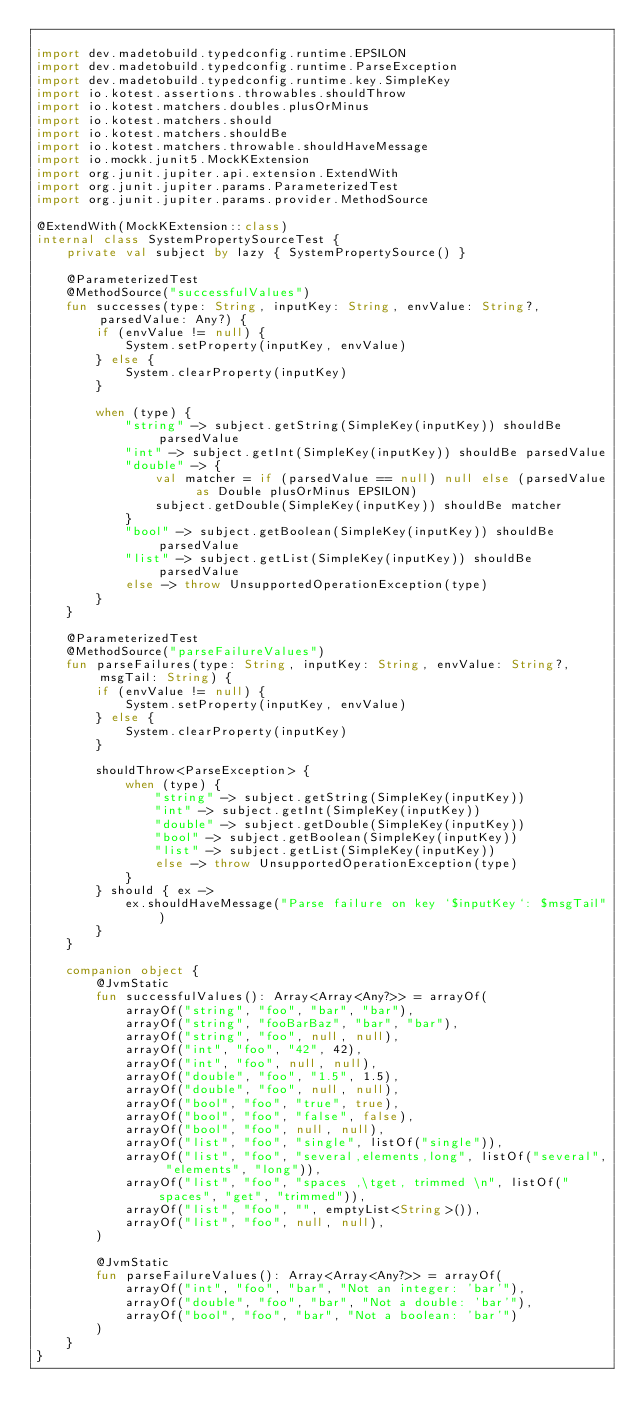<code> <loc_0><loc_0><loc_500><loc_500><_Kotlin_>
import dev.madetobuild.typedconfig.runtime.EPSILON
import dev.madetobuild.typedconfig.runtime.ParseException
import dev.madetobuild.typedconfig.runtime.key.SimpleKey
import io.kotest.assertions.throwables.shouldThrow
import io.kotest.matchers.doubles.plusOrMinus
import io.kotest.matchers.should
import io.kotest.matchers.shouldBe
import io.kotest.matchers.throwable.shouldHaveMessage
import io.mockk.junit5.MockKExtension
import org.junit.jupiter.api.extension.ExtendWith
import org.junit.jupiter.params.ParameterizedTest
import org.junit.jupiter.params.provider.MethodSource

@ExtendWith(MockKExtension::class)
internal class SystemPropertySourceTest {
    private val subject by lazy { SystemPropertySource() }

    @ParameterizedTest
    @MethodSource("successfulValues")
    fun successes(type: String, inputKey: String, envValue: String?, parsedValue: Any?) {
        if (envValue != null) {
            System.setProperty(inputKey, envValue)
        } else {
            System.clearProperty(inputKey)
        }

        when (type) {
            "string" -> subject.getString(SimpleKey(inputKey)) shouldBe parsedValue
            "int" -> subject.getInt(SimpleKey(inputKey)) shouldBe parsedValue
            "double" -> {
                val matcher = if (parsedValue == null) null else (parsedValue as Double plusOrMinus EPSILON)
                subject.getDouble(SimpleKey(inputKey)) shouldBe matcher
            }
            "bool" -> subject.getBoolean(SimpleKey(inputKey)) shouldBe parsedValue
            "list" -> subject.getList(SimpleKey(inputKey)) shouldBe parsedValue
            else -> throw UnsupportedOperationException(type)
        }
    }

    @ParameterizedTest
    @MethodSource("parseFailureValues")
    fun parseFailures(type: String, inputKey: String, envValue: String?, msgTail: String) {
        if (envValue != null) {
            System.setProperty(inputKey, envValue)
        } else {
            System.clearProperty(inputKey)
        }

        shouldThrow<ParseException> {
            when (type) {
                "string" -> subject.getString(SimpleKey(inputKey))
                "int" -> subject.getInt(SimpleKey(inputKey))
                "double" -> subject.getDouble(SimpleKey(inputKey))
                "bool" -> subject.getBoolean(SimpleKey(inputKey))
                "list" -> subject.getList(SimpleKey(inputKey))
                else -> throw UnsupportedOperationException(type)
            }
        } should { ex ->
            ex.shouldHaveMessage("Parse failure on key `$inputKey`: $msgTail")
        }
    }

    companion object {
        @JvmStatic
        fun successfulValues(): Array<Array<Any?>> = arrayOf(
            arrayOf("string", "foo", "bar", "bar"),
            arrayOf("string", "fooBarBaz", "bar", "bar"),
            arrayOf("string", "foo", null, null),
            arrayOf("int", "foo", "42", 42),
            arrayOf("int", "foo", null, null),
            arrayOf("double", "foo", "1.5", 1.5),
            arrayOf("double", "foo", null, null),
            arrayOf("bool", "foo", "true", true),
            arrayOf("bool", "foo", "false", false),
            arrayOf("bool", "foo", null, null),
            arrayOf("list", "foo", "single", listOf("single")),
            arrayOf("list", "foo", "several,elements,long", listOf("several", "elements", "long")),
            arrayOf("list", "foo", "spaces ,\tget, trimmed \n", listOf("spaces", "get", "trimmed")),
            arrayOf("list", "foo", "", emptyList<String>()),
            arrayOf("list", "foo", null, null),
        )

        @JvmStatic
        fun parseFailureValues(): Array<Array<Any?>> = arrayOf(
            arrayOf("int", "foo", "bar", "Not an integer: 'bar'"),
            arrayOf("double", "foo", "bar", "Not a double: 'bar'"),
            arrayOf("bool", "foo", "bar", "Not a boolean: 'bar'")
        )
    }
}
</code> 